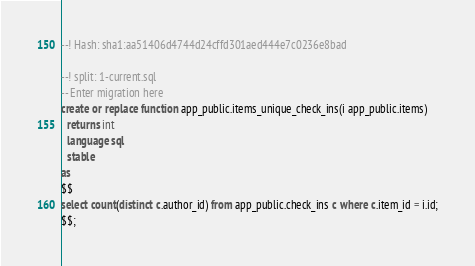<code> <loc_0><loc_0><loc_500><loc_500><_SQL_>--! Hash: sha1:aa51406d4744d24cffd301aed444e7c0236e8bad

--! split: 1-current.sql
-- Enter migration here
create or replace function app_public.items_unique_check_ins(i app_public.items)
  returns int
  language sql
  stable
as
$$
select count(distinct c.author_id) from app_public.check_ins c where c.item_id = i.id;
$$;
</code> 